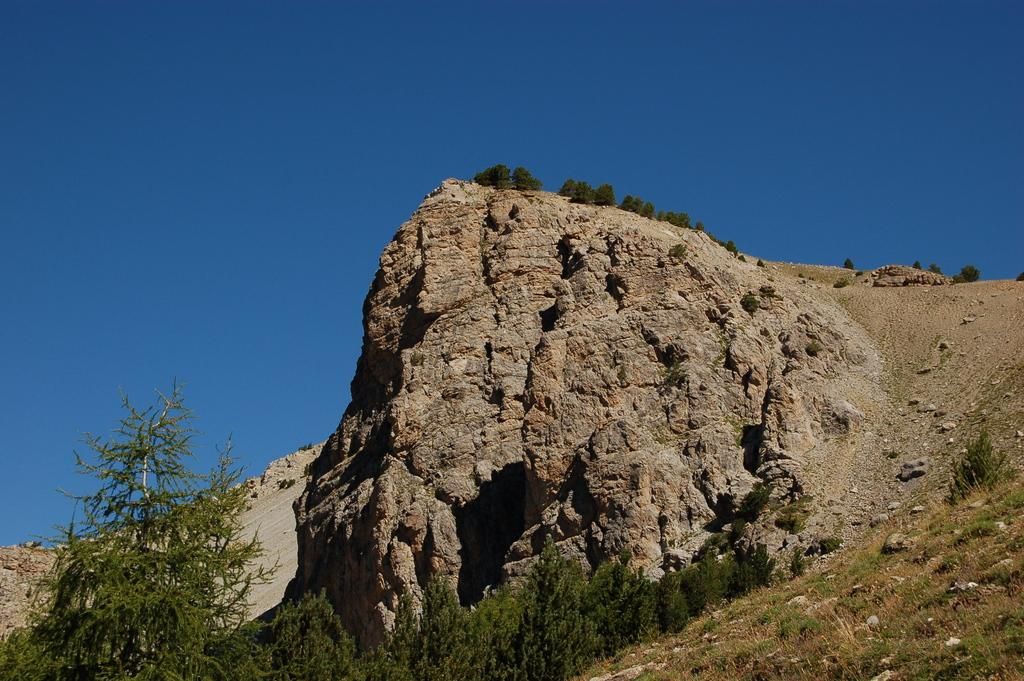What is the main feature in the image? There is a mountain in the image. What can be seen on the mountain? There are trees on the mountain. What is present at the bottom of the image? There is a group of trees and plants at the bottom of the image. What is visible at the top of the image? The sky is visible at the top of the image. How would you describe the sky in the image? The sky appears clear in the image. How many spiders are crawling on the mountain in the image? There are no spiders visible in the image; it only features a mountain, trees, and a clear sky. 